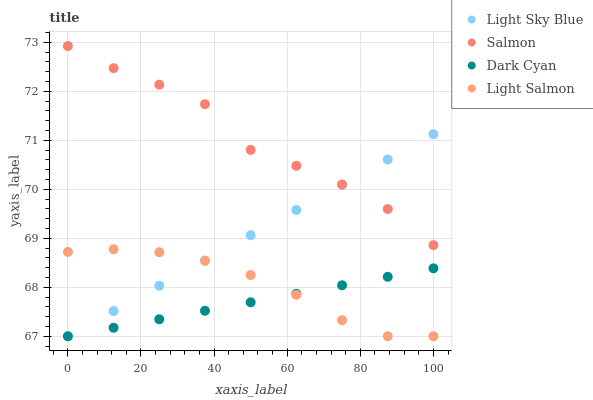Does Dark Cyan have the minimum area under the curve?
Answer yes or no. Yes. Does Salmon have the maximum area under the curve?
Answer yes or no. Yes. Does Light Salmon have the minimum area under the curve?
Answer yes or no. No. Does Light Salmon have the maximum area under the curve?
Answer yes or no. No. Is Dark Cyan the smoothest?
Answer yes or no. Yes. Is Salmon the roughest?
Answer yes or no. Yes. Is Light Salmon the smoothest?
Answer yes or no. No. Is Light Salmon the roughest?
Answer yes or no. No. Does Dark Cyan have the lowest value?
Answer yes or no. Yes. Does Salmon have the lowest value?
Answer yes or no. No. Does Salmon have the highest value?
Answer yes or no. Yes. Does Light Salmon have the highest value?
Answer yes or no. No. Is Dark Cyan less than Salmon?
Answer yes or no. Yes. Is Salmon greater than Dark Cyan?
Answer yes or no. Yes. Does Light Salmon intersect Light Sky Blue?
Answer yes or no. Yes. Is Light Salmon less than Light Sky Blue?
Answer yes or no. No. Is Light Salmon greater than Light Sky Blue?
Answer yes or no. No. Does Dark Cyan intersect Salmon?
Answer yes or no. No. 